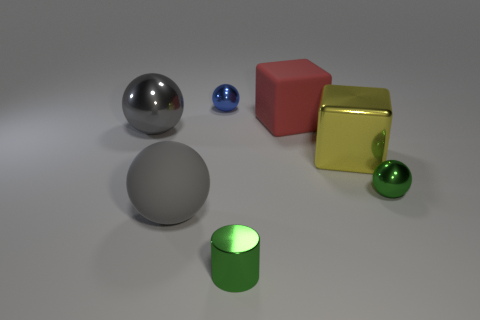Are there more matte objects on the right side of the blue sphere than gray metal balls behind the big red matte object?
Offer a very short reply. Yes. What color is the tiny sphere behind the big rubber thing to the right of the small shiny thing that is behind the big red matte block?
Offer a very short reply. Blue. There is a sphere that is behind the red matte thing; is it the same color as the cylinder?
Your answer should be very brief. No. How many other things are there of the same color as the metallic cylinder?
Provide a short and direct response. 1. How many objects are spheres or matte objects?
Ensure brevity in your answer.  5. How many things are either tiny metal cylinders or big objects that are right of the green cylinder?
Offer a terse response. 3. Is the material of the small green sphere the same as the red block?
Provide a short and direct response. No. How many other objects are the same material as the large red object?
Offer a terse response. 1. Are there more tiny gray spheres than red matte things?
Your answer should be compact. No. There is a big gray rubber object on the left side of the big yellow metallic object; is its shape the same as the red thing?
Your response must be concise. No. 